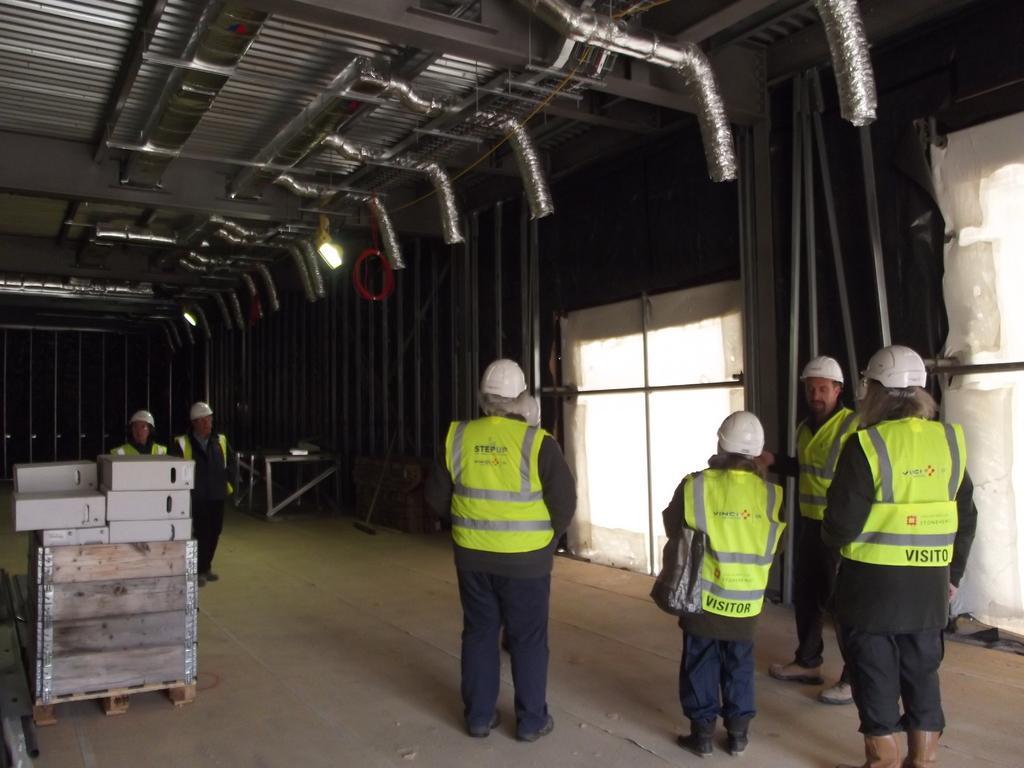Describe this image in one or two sentences. In this image I can see group of people standing. There are boxes, poles lights, tables and there are some other objects. 